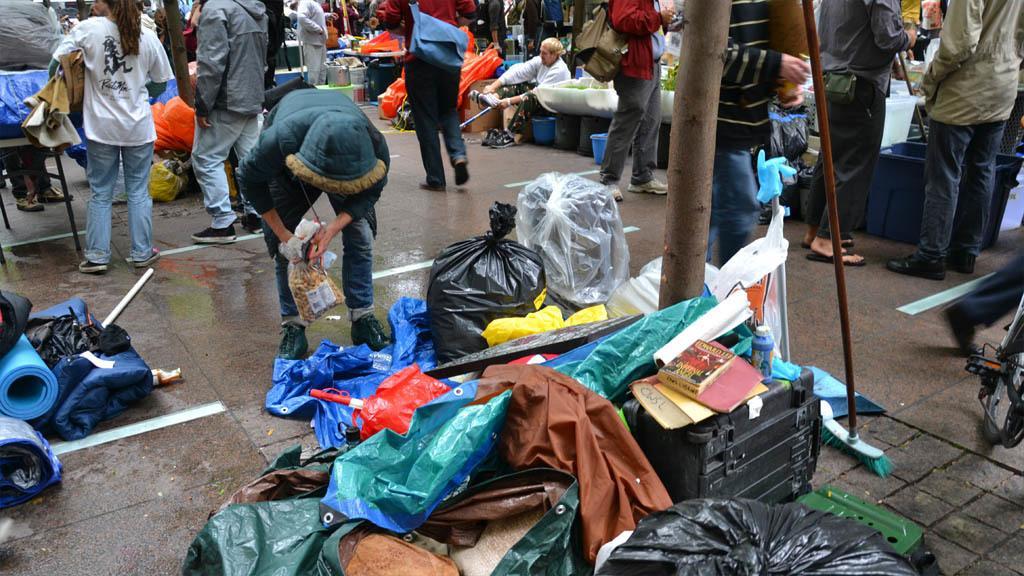How would you summarize this image in a sentence or two? In this image we can see the people. We can also see the barks of the trees. Image also consists of the floor cleaning brush, suitcase, books, bottle, covers and also some roles on the path. In the background, we can see some person sitting. We can also see the covers, buckets and also some other objects. 